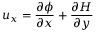Convert formula to latex. <formula><loc_0><loc_0><loc_500><loc_500>u _ { x } = \frac { \partial \phi } { \partial x } + \frac { \partial H } { \partial y }</formula> 